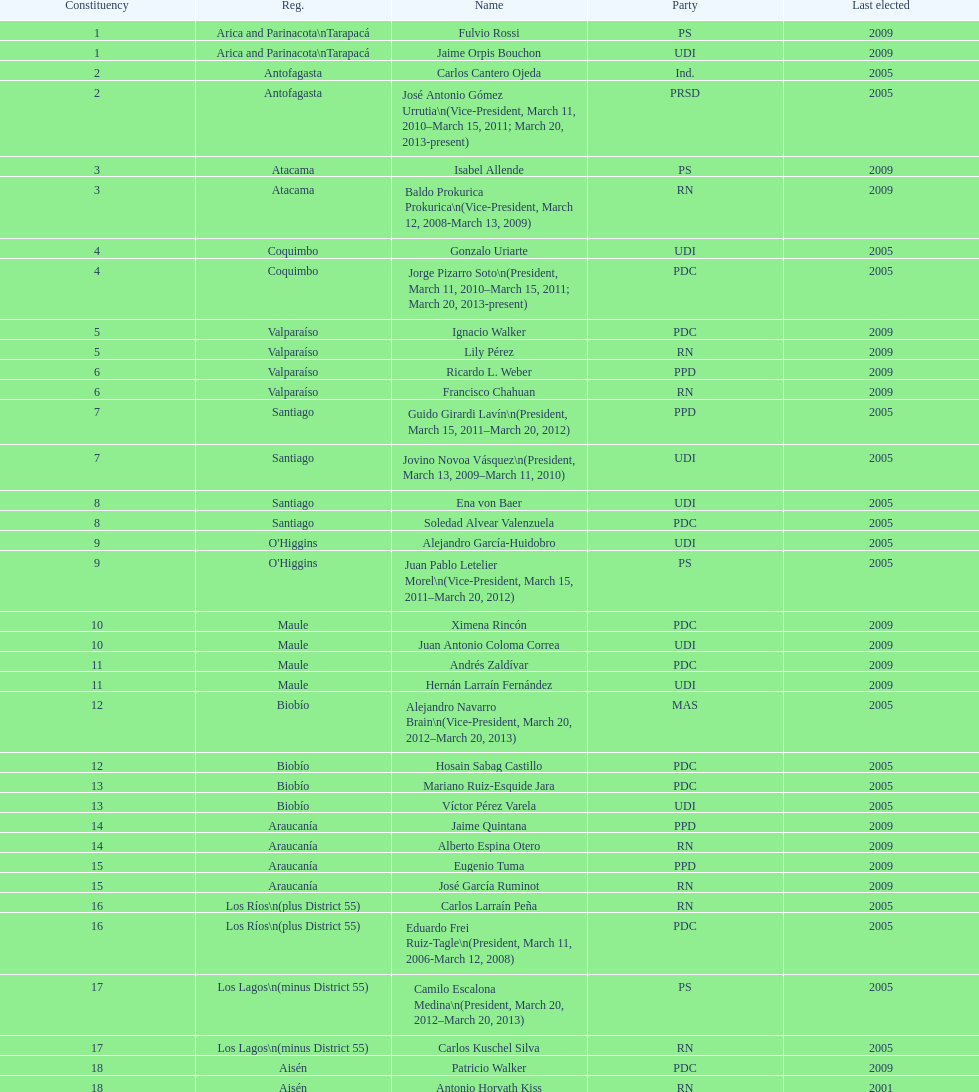Which region is mentioned last in the table? Magallanes. 